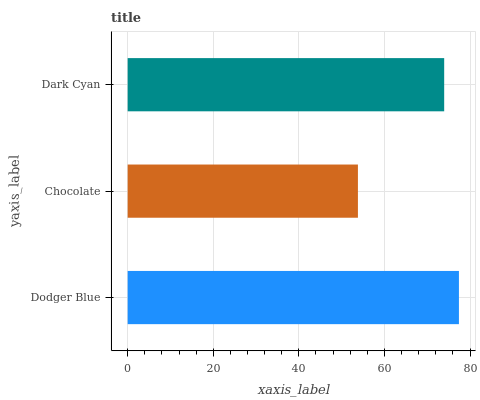Is Chocolate the minimum?
Answer yes or no. Yes. Is Dodger Blue the maximum?
Answer yes or no. Yes. Is Dark Cyan the minimum?
Answer yes or no. No. Is Dark Cyan the maximum?
Answer yes or no. No. Is Dark Cyan greater than Chocolate?
Answer yes or no. Yes. Is Chocolate less than Dark Cyan?
Answer yes or no. Yes. Is Chocolate greater than Dark Cyan?
Answer yes or no. No. Is Dark Cyan less than Chocolate?
Answer yes or no. No. Is Dark Cyan the high median?
Answer yes or no. Yes. Is Dark Cyan the low median?
Answer yes or no. Yes. Is Chocolate the high median?
Answer yes or no. No. Is Chocolate the low median?
Answer yes or no. No. 